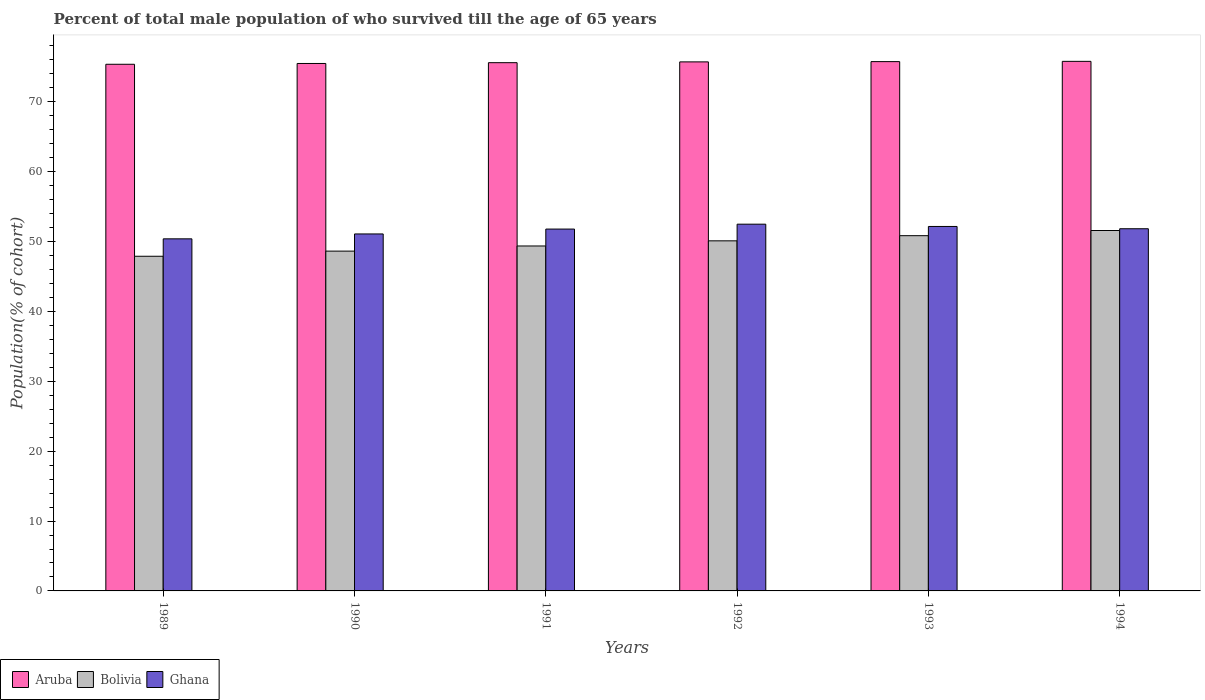How many different coloured bars are there?
Provide a short and direct response. 3. How many groups of bars are there?
Offer a very short reply. 6. Are the number of bars on each tick of the X-axis equal?
Give a very brief answer. Yes. How many bars are there on the 6th tick from the right?
Provide a succinct answer. 3. What is the label of the 5th group of bars from the left?
Offer a terse response. 1993. What is the percentage of total male population who survived till the age of 65 years in Bolivia in 1992?
Provide a short and direct response. 50.11. Across all years, what is the maximum percentage of total male population who survived till the age of 65 years in Ghana?
Keep it short and to the point. 52.5. Across all years, what is the minimum percentage of total male population who survived till the age of 65 years in Aruba?
Ensure brevity in your answer.  75.38. In which year was the percentage of total male population who survived till the age of 65 years in Aruba maximum?
Your response must be concise. 1994. In which year was the percentage of total male population who survived till the age of 65 years in Bolivia minimum?
Offer a terse response. 1989. What is the total percentage of total male population who survived till the age of 65 years in Ghana in the graph?
Your response must be concise. 309.8. What is the difference between the percentage of total male population who survived till the age of 65 years in Ghana in 1989 and that in 1991?
Keep it short and to the point. -1.4. What is the difference between the percentage of total male population who survived till the age of 65 years in Ghana in 1991 and the percentage of total male population who survived till the age of 65 years in Aruba in 1990?
Your answer should be very brief. -23.7. What is the average percentage of total male population who survived till the age of 65 years in Bolivia per year?
Make the answer very short. 49.74. In the year 1990, what is the difference between the percentage of total male population who survived till the age of 65 years in Bolivia and percentage of total male population who survived till the age of 65 years in Ghana?
Offer a terse response. -2.46. What is the ratio of the percentage of total male population who survived till the age of 65 years in Bolivia in 1991 to that in 1992?
Keep it short and to the point. 0.99. What is the difference between the highest and the second highest percentage of total male population who survived till the age of 65 years in Ghana?
Your answer should be very brief. 0.33. What is the difference between the highest and the lowest percentage of total male population who survived till the age of 65 years in Bolivia?
Make the answer very short. 3.68. In how many years, is the percentage of total male population who survived till the age of 65 years in Ghana greater than the average percentage of total male population who survived till the age of 65 years in Ghana taken over all years?
Your answer should be compact. 4. Is the sum of the percentage of total male population who survived till the age of 65 years in Aruba in 1989 and 1990 greater than the maximum percentage of total male population who survived till the age of 65 years in Bolivia across all years?
Ensure brevity in your answer.  Yes. What does the 1st bar from the right in 1989 represents?
Offer a terse response. Ghana. Are all the bars in the graph horizontal?
Provide a succinct answer. No. How many years are there in the graph?
Keep it short and to the point. 6. What is the difference between two consecutive major ticks on the Y-axis?
Your response must be concise. 10. Does the graph contain any zero values?
Keep it short and to the point. No. Does the graph contain grids?
Your response must be concise. No. How are the legend labels stacked?
Provide a short and direct response. Horizontal. What is the title of the graph?
Your answer should be very brief. Percent of total male population of who survived till the age of 65 years. Does "Fiji" appear as one of the legend labels in the graph?
Your answer should be very brief. No. What is the label or title of the X-axis?
Your answer should be very brief. Years. What is the label or title of the Y-axis?
Offer a terse response. Population(% of cohort). What is the Population(% of cohort) in Aruba in 1989?
Your answer should be very brief. 75.38. What is the Population(% of cohort) of Bolivia in 1989?
Give a very brief answer. 47.9. What is the Population(% of cohort) of Ghana in 1989?
Your answer should be very brief. 50.4. What is the Population(% of cohort) in Aruba in 1990?
Keep it short and to the point. 75.5. What is the Population(% of cohort) in Bolivia in 1990?
Keep it short and to the point. 48.64. What is the Population(% of cohort) in Ghana in 1990?
Offer a terse response. 51.1. What is the Population(% of cohort) of Aruba in 1991?
Provide a short and direct response. 75.61. What is the Population(% of cohort) of Bolivia in 1991?
Offer a very short reply. 49.37. What is the Population(% of cohort) in Ghana in 1991?
Give a very brief answer. 51.8. What is the Population(% of cohort) in Aruba in 1992?
Ensure brevity in your answer.  75.73. What is the Population(% of cohort) of Bolivia in 1992?
Give a very brief answer. 50.11. What is the Population(% of cohort) of Ghana in 1992?
Make the answer very short. 52.5. What is the Population(% of cohort) of Aruba in 1993?
Make the answer very short. 75.76. What is the Population(% of cohort) of Bolivia in 1993?
Make the answer very short. 50.85. What is the Population(% of cohort) in Ghana in 1993?
Give a very brief answer. 52.17. What is the Population(% of cohort) of Aruba in 1994?
Keep it short and to the point. 75.8. What is the Population(% of cohort) of Bolivia in 1994?
Provide a succinct answer. 51.59. What is the Population(% of cohort) of Ghana in 1994?
Make the answer very short. 51.84. Across all years, what is the maximum Population(% of cohort) in Aruba?
Provide a short and direct response. 75.8. Across all years, what is the maximum Population(% of cohort) in Bolivia?
Offer a very short reply. 51.59. Across all years, what is the maximum Population(% of cohort) of Ghana?
Make the answer very short. 52.5. Across all years, what is the minimum Population(% of cohort) in Aruba?
Provide a short and direct response. 75.38. Across all years, what is the minimum Population(% of cohort) in Bolivia?
Provide a short and direct response. 47.9. Across all years, what is the minimum Population(% of cohort) of Ghana?
Keep it short and to the point. 50.4. What is the total Population(% of cohort) in Aruba in the graph?
Your response must be concise. 453.78. What is the total Population(% of cohort) in Bolivia in the graph?
Make the answer very short. 298.46. What is the total Population(% of cohort) in Ghana in the graph?
Provide a succinct answer. 309.8. What is the difference between the Population(% of cohort) in Aruba in 1989 and that in 1990?
Offer a terse response. -0.11. What is the difference between the Population(% of cohort) of Bolivia in 1989 and that in 1990?
Make the answer very short. -0.74. What is the difference between the Population(% of cohort) of Ghana in 1989 and that in 1990?
Provide a short and direct response. -0.7. What is the difference between the Population(% of cohort) in Aruba in 1989 and that in 1991?
Ensure brevity in your answer.  -0.23. What is the difference between the Population(% of cohort) in Bolivia in 1989 and that in 1991?
Your response must be concise. -1.47. What is the difference between the Population(% of cohort) of Ghana in 1989 and that in 1991?
Your answer should be compact. -1.4. What is the difference between the Population(% of cohort) of Aruba in 1989 and that in 1992?
Keep it short and to the point. -0.34. What is the difference between the Population(% of cohort) in Bolivia in 1989 and that in 1992?
Make the answer very short. -2.21. What is the difference between the Population(% of cohort) in Ghana in 1989 and that in 1992?
Ensure brevity in your answer.  -2.1. What is the difference between the Population(% of cohort) of Aruba in 1989 and that in 1993?
Your answer should be compact. -0.38. What is the difference between the Population(% of cohort) of Bolivia in 1989 and that in 1993?
Give a very brief answer. -2.95. What is the difference between the Population(% of cohort) of Ghana in 1989 and that in 1993?
Make the answer very short. -1.77. What is the difference between the Population(% of cohort) in Aruba in 1989 and that in 1994?
Give a very brief answer. -0.42. What is the difference between the Population(% of cohort) in Bolivia in 1989 and that in 1994?
Your answer should be compact. -3.68. What is the difference between the Population(% of cohort) in Ghana in 1989 and that in 1994?
Offer a very short reply. -1.45. What is the difference between the Population(% of cohort) of Aruba in 1990 and that in 1991?
Keep it short and to the point. -0.11. What is the difference between the Population(% of cohort) of Bolivia in 1990 and that in 1991?
Your answer should be very brief. -0.74. What is the difference between the Population(% of cohort) in Ghana in 1990 and that in 1991?
Your response must be concise. -0.7. What is the difference between the Population(% of cohort) of Aruba in 1990 and that in 1992?
Give a very brief answer. -0.23. What is the difference between the Population(% of cohort) in Bolivia in 1990 and that in 1992?
Your response must be concise. -1.47. What is the difference between the Population(% of cohort) of Ghana in 1990 and that in 1992?
Offer a very short reply. -1.4. What is the difference between the Population(% of cohort) of Aruba in 1990 and that in 1993?
Offer a terse response. -0.27. What is the difference between the Population(% of cohort) in Bolivia in 1990 and that in 1993?
Keep it short and to the point. -2.21. What is the difference between the Population(% of cohort) in Ghana in 1990 and that in 1993?
Make the answer very short. -1.07. What is the difference between the Population(% of cohort) in Aruba in 1990 and that in 1994?
Your response must be concise. -0.3. What is the difference between the Population(% of cohort) in Bolivia in 1990 and that in 1994?
Your answer should be very brief. -2.95. What is the difference between the Population(% of cohort) of Ghana in 1990 and that in 1994?
Provide a succinct answer. -0.75. What is the difference between the Population(% of cohort) of Aruba in 1991 and that in 1992?
Ensure brevity in your answer.  -0.11. What is the difference between the Population(% of cohort) of Bolivia in 1991 and that in 1992?
Your answer should be very brief. -0.74. What is the difference between the Population(% of cohort) in Ghana in 1991 and that in 1992?
Give a very brief answer. -0.7. What is the difference between the Population(% of cohort) in Aruba in 1991 and that in 1993?
Make the answer very short. -0.15. What is the difference between the Population(% of cohort) in Bolivia in 1991 and that in 1993?
Ensure brevity in your answer.  -1.47. What is the difference between the Population(% of cohort) in Ghana in 1991 and that in 1993?
Offer a very short reply. -0.37. What is the difference between the Population(% of cohort) of Aruba in 1991 and that in 1994?
Offer a very short reply. -0.19. What is the difference between the Population(% of cohort) of Bolivia in 1991 and that in 1994?
Provide a short and direct response. -2.21. What is the difference between the Population(% of cohort) of Ghana in 1991 and that in 1994?
Make the answer very short. -0.05. What is the difference between the Population(% of cohort) of Aruba in 1992 and that in 1993?
Your answer should be very brief. -0.04. What is the difference between the Population(% of cohort) in Bolivia in 1992 and that in 1993?
Your response must be concise. -0.74. What is the difference between the Population(% of cohort) in Ghana in 1992 and that in 1993?
Make the answer very short. 0.33. What is the difference between the Population(% of cohort) in Aruba in 1992 and that in 1994?
Provide a succinct answer. -0.08. What is the difference between the Population(% of cohort) of Bolivia in 1992 and that in 1994?
Your answer should be very brief. -1.48. What is the difference between the Population(% of cohort) in Ghana in 1992 and that in 1994?
Make the answer very short. 0.65. What is the difference between the Population(% of cohort) of Aruba in 1993 and that in 1994?
Provide a succinct answer. -0.04. What is the difference between the Population(% of cohort) in Bolivia in 1993 and that in 1994?
Provide a short and direct response. -0.74. What is the difference between the Population(% of cohort) of Ghana in 1993 and that in 1994?
Your response must be concise. 0.33. What is the difference between the Population(% of cohort) in Aruba in 1989 and the Population(% of cohort) in Bolivia in 1990?
Offer a terse response. 26.74. What is the difference between the Population(% of cohort) in Aruba in 1989 and the Population(% of cohort) in Ghana in 1990?
Your answer should be very brief. 24.29. What is the difference between the Population(% of cohort) of Bolivia in 1989 and the Population(% of cohort) of Ghana in 1990?
Provide a short and direct response. -3.19. What is the difference between the Population(% of cohort) of Aruba in 1989 and the Population(% of cohort) of Bolivia in 1991?
Your answer should be compact. 26.01. What is the difference between the Population(% of cohort) in Aruba in 1989 and the Population(% of cohort) in Ghana in 1991?
Make the answer very short. 23.59. What is the difference between the Population(% of cohort) of Bolivia in 1989 and the Population(% of cohort) of Ghana in 1991?
Provide a succinct answer. -3.89. What is the difference between the Population(% of cohort) in Aruba in 1989 and the Population(% of cohort) in Bolivia in 1992?
Offer a terse response. 25.27. What is the difference between the Population(% of cohort) of Aruba in 1989 and the Population(% of cohort) of Ghana in 1992?
Keep it short and to the point. 22.89. What is the difference between the Population(% of cohort) in Bolivia in 1989 and the Population(% of cohort) in Ghana in 1992?
Make the answer very short. -4.59. What is the difference between the Population(% of cohort) in Aruba in 1989 and the Population(% of cohort) in Bolivia in 1993?
Your answer should be compact. 24.53. What is the difference between the Population(% of cohort) in Aruba in 1989 and the Population(% of cohort) in Ghana in 1993?
Your response must be concise. 23.21. What is the difference between the Population(% of cohort) of Bolivia in 1989 and the Population(% of cohort) of Ghana in 1993?
Provide a succinct answer. -4.27. What is the difference between the Population(% of cohort) in Aruba in 1989 and the Population(% of cohort) in Bolivia in 1994?
Your answer should be very brief. 23.8. What is the difference between the Population(% of cohort) of Aruba in 1989 and the Population(% of cohort) of Ghana in 1994?
Your answer should be very brief. 23.54. What is the difference between the Population(% of cohort) in Bolivia in 1989 and the Population(% of cohort) in Ghana in 1994?
Your response must be concise. -3.94. What is the difference between the Population(% of cohort) of Aruba in 1990 and the Population(% of cohort) of Bolivia in 1991?
Provide a succinct answer. 26.12. What is the difference between the Population(% of cohort) of Aruba in 1990 and the Population(% of cohort) of Ghana in 1991?
Offer a very short reply. 23.7. What is the difference between the Population(% of cohort) of Bolivia in 1990 and the Population(% of cohort) of Ghana in 1991?
Offer a terse response. -3.16. What is the difference between the Population(% of cohort) of Aruba in 1990 and the Population(% of cohort) of Bolivia in 1992?
Provide a short and direct response. 25.39. What is the difference between the Population(% of cohort) in Aruba in 1990 and the Population(% of cohort) in Ghana in 1992?
Make the answer very short. 23. What is the difference between the Population(% of cohort) in Bolivia in 1990 and the Population(% of cohort) in Ghana in 1992?
Ensure brevity in your answer.  -3.86. What is the difference between the Population(% of cohort) of Aruba in 1990 and the Population(% of cohort) of Bolivia in 1993?
Keep it short and to the point. 24.65. What is the difference between the Population(% of cohort) of Aruba in 1990 and the Population(% of cohort) of Ghana in 1993?
Offer a very short reply. 23.33. What is the difference between the Population(% of cohort) in Bolivia in 1990 and the Population(% of cohort) in Ghana in 1993?
Offer a terse response. -3.53. What is the difference between the Population(% of cohort) of Aruba in 1990 and the Population(% of cohort) of Bolivia in 1994?
Offer a very short reply. 23.91. What is the difference between the Population(% of cohort) of Aruba in 1990 and the Population(% of cohort) of Ghana in 1994?
Your answer should be very brief. 23.65. What is the difference between the Population(% of cohort) in Bolivia in 1990 and the Population(% of cohort) in Ghana in 1994?
Your response must be concise. -3.2. What is the difference between the Population(% of cohort) in Aruba in 1991 and the Population(% of cohort) in Bolivia in 1992?
Ensure brevity in your answer.  25.5. What is the difference between the Population(% of cohort) in Aruba in 1991 and the Population(% of cohort) in Ghana in 1992?
Ensure brevity in your answer.  23.12. What is the difference between the Population(% of cohort) in Bolivia in 1991 and the Population(% of cohort) in Ghana in 1992?
Keep it short and to the point. -3.12. What is the difference between the Population(% of cohort) in Aruba in 1991 and the Population(% of cohort) in Bolivia in 1993?
Give a very brief answer. 24.76. What is the difference between the Population(% of cohort) in Aruba in 1991 and the Population(% of cohort) in Ghana in 1993?
Offer a terse response. 23.44. What is the difference between the Population(% of cohort) in Bolivia in 1991 and the Population(% of cohort) in Ghana in 1993?
Provide a short and direct response. -2.79. What is the difference between the Population(% of cohort) of Aruba in 1991 and the Population(% of cohort) of Bolivia in 1994?
Provide a short and direct response. 24.02. What is the difference between the Population(% of cohort) of Aruba in 1991 and the Population(% of cohort) of Ghana in 1994?
Offer a very short reply. 23.77. What is the difference between the Population(% of cohort) in Bolivia in 1991 and the Population(% of cohort) in Ghana in 1994?
Make the answer very short. -2.47. What is the difference between the Population(% of cohort) of Aruba in 1992 and the Population(% of cohort) of Bolivia in 1993?
Provide a succinct answer. 24.88. What is the difference between the Population(% of cohort) in Aruba in 1992 and the Population(% of cohort) in Ghana in 1993?
Provide a succinct answer. 23.56. What is the difference between the Population(% of cohort) in Bolivia in 1992 and the Population(% of cohort) in Ghana in 1993?
Your answer should be compact. -2.06. What is the difference between the Population(% of cohort) of Aruba in 1992 and the Population(% of cohort) of Bolivia in 1994?
Ensure brevity in your answer.  24.14. What is the difference between the Population(% of cohort) of Aruba in 1992 and the Population(% of cohort) of Ghana in 1994?
Your response must be concise. 23.88. What is the difference between the Population(% of cohort) in Bolivia in 1992 and the Population(% of cohort) in Ghana in 1994?
Your response must be concise. -1.73. What is the difference between the Population(% of cohort) in Aruba in 1993 and the Population(% of cohort) in Bolivia in 1994?
Your answer should be very brief. 24.18. What is the difference between the Population(% of cohort) of Aruba in 1993 and the Population(% of cohort) of Ghana in 1994?
Make the answer very short. 23.92. What is the difference between the Population(% of cohort) in Bolivia in 1993 and the Population(% of cohort) in Ghana in 1994?
Your answer should be compact. -0.99. What is the average Population(% of cohort) of Aruba per year?
Provide a short and direct response. 75.63. What is the average Population(% of cohort) of Bolivia per year?
Your response must be concise. 49.74. What is the average Population(% of cohort) in Ghana per year?
Provide a short and direct response. 51.63. In the year 1989, what is the difference between the Population(% of cohort) of Aruba and Population(% of cohort) of Bolivia?
Offer a terse response. 27.48. In the year 1989, what is the difference between the Population(% of cohort) in Aruba and Population(% of cohort) in Ghana?
Keep it short and to the point. 24.99. In the year 1989, what is the difference between the Population(% of cohort) of Bolivia and Population(% of cohort) of Ghana?
Make the answer very short. -2.49. In the year 1990, what is the difference between the Population(% of cohort) of Aruba and Population(% of cohort) of Bolivia?
Your answer should be very brief. 26.86. In the year 1990, what is the difference between the Population(% of cohort) of Aruba and Population(% of cohort) of Ghana?
Provide a short and direct response. 24.4. In the year 1990, what is the difference between the Population(% of cohort) in Bolivia and Population(% of cohort) in Ghana?
Offer a terse response. -2.46. In the year 1991, what is the difference between the Population(% of cohort) in Aruba and Population(% of cohort) in Bolivia?
Keep it short and to the point. 26.24. In the year 1991, what is the difference between the Population(% of cohort) in Aruba and Population(% of cohort) in Ghana?
Your response must be concise. 23.82. In the year 1991, what is the difference between the Population(% of cohort) in Bolivia and Population(% of cohort) in Ghana?
Make the answer very short. -2.42. In the year 1992, what is the difference between the Population(% of cohort) of Aruba and Population(% of cohort) of Bolivia?
Provide a succinct answer. 25.62. In the year 1992, what is the difference between the Population(% of cohort) in Aruba and Population(% of cohort) in Ghana?
Provide a short and direct response. 23.23. In the year 1992, what is the difference between the Population(% of cohort) in Bolivia and Population(% of cohort) in Ghana?
Your response must be concise. -2.39. In the year 1993, what is the difference between the Population(% of cohort) in Aruba and Population(% of cohort) in Bolivia?
Your answer should be compact. 24.91. In the year 1993, what is the difference between the Population(% of cohort) of Aruba and Population(% of cohort) of Ghana?
Ensure brevity in your answer.  23.59. In the year 1993, what is the difference between the Population(% of cohort) in Bolivia and Population(% of cohort) in Ghana?
Offer a very short reply. -1.32. In the year 1994, what is the difference between the Population(% of cohort) of Aruba and Population(% of cohort) of Bolivia?
Provide a short and direct response. 24.21. In the year 1994, what is the difference between the Population(% of cohort) in Aruba and Population(% of cohort) in Ghana?
Your answer should be compact. 23.96. In the year 1994, what is the difference between the Population(% of cohort) in Bolivia and Population(% of cohort) in Ghana?
Give a very brief answer. -0.25. What is the ratio of the Population(% of cohort) in Aruba in 1989 to that in 1990?
Give a very brief answer. 1. What is the ratio of the Population(% of cohort) of Bolivia in 1989 to that in 1990?
Your answer should be compact. 0.98. What is the ratio of the Population(% of cohort) of Ghana in 1989 to that in 1990?
Offer a terse response. 0.99. What is the ratio of the Population(% of cohort) of Aruba in 1989 to that in 1991?
Your answer should be very brief. 1. What is the ratio of the Population(% of cohort) of Bolivia in 1989 to that in 1991?
Provide a succinct answer. 0.97. What is the ratio of the Population(% of cohort) in Bolivia in 1989 to that in 1992?
Provide a succinct answer. 0.96. What is the ratio of the Population(% of cohort) in Ghana in 1989 to that in 1992?
Provide a succinct answer. 0.96. What is the ratio of the Population(% of cohort) of Bolivia in 1989 to that in 1993?
Offer a very short reply. 0.94. What is the ratio of the Population(% of cohort) in Bolivia in 1989 to that in 1994?
Provide a succinct answer. 0.93. What is the ratio of the Population(% of cohort) of Ghana in 1989 to that in 1994?
Ensure brevity in your answer.  0.97. What is the ratio of the Population(% of cohort) of Aruba in 1990 to that in 1991?
Your response must be concise. 1. What is the ratio of the Population(% of cohort) in Bolivia in 1990 to that in 1991?
Provide a short and direct response. 0.99. What is the ratio of the Population(% of cohort) of Ghana in 1990 to that in 1991?
Offer a terse response. 0.99. What is the ratio of the Population(% of cohort) in Bolivia in 1990 to that in 1992?
Give a very brief answer. 0.97. What is the ratio of the Population(% of cohort) of Ghana in 1990 to that in 1992?
Offer a terse response. 0.97. What is the ratio of the Population(% of cohort) in Bolivia in 1990 to that in 1993?
Offer a very short reply. 0.96. What is the ratio of the Population(% of cohort) in Ghana in 1990 to that in 1993?
Your answer should be compact. 0.98. What is the ratio of the Population(% of cohort) in Bolivia in 1990 to that in 1994?
Offer a terse response. 0.94. What is the ratio of the Population(% of cohort) in Ghana in 1990 to that in 1994?
Your answer should be compact. 0.99. What is the ratio of the Population(% of cohort) of Aruba in 1991 to that in 1992?
Offer a terse response. 1. What is the ratio of the Population(% of cohort) in Ghana in 1991 to that in 1992?
Ensure brevity in your answer.  0.99. What is the ratio of the Population(% of cohort) of Aruba in 1991 to that in 1993?
Offer a terse response. 1. What is the ratio of the Population(% of cohort) of Bolivia in 1991 to that in 1993?
Offer a terse response. 0.97. What is the ratio of the Population(% of cohort) of Aruba in 1991 to that in 1994?
Make the answer very short. 1. What is the ratio of the Population(% of cohort) in Bolivia in 1991 to that in 1994?
Provide a succinct answer. 0.96. What is the ratio of the Population(% of cohort) of Ghana in 1991 to that in 1994?
Make the answer very short. 1. What is the ratio of the Population(% of cohort) of Aruba in 1992 to that in 1993?
Keep it short and to the point. 1. What is the ratio of the Population(% of cohort) of Bolivia in 1992 to that in 1993?
Your response must be concise. 0.99. What is the ratio of the Population(% of cohort) in Bolivia in 1992 to that in 1994?
Provide a short and direct response. 0.97. What is the ratio of the Population(% of cohort) in Ghana in 1992 to that in 1994?
Make the answer very short. 1.01. What is the ratio of the Population(% of cohort) of Aruba in 1993 to that in 1994?
Offer a terse response. 1. What is the ratio of the Population(% of cohort) in Bolivia in 1993 to that in 1994?
Keep it short and to the point. 0.99. What is the difference between the highest and the second highest Population(% of cohort) in Aruba?
Offer a terse response. 0.04. What is the difference between the highest and the second highest Population(% of cohort) in Bolivia?
Provide a succinct answer. 0.74. What is the difference between the highest and the second highest Population(% of cohort) of Ghana?
Ensure brevity in your answer.  0.33. What is the difference between the highest and the lowest Population(% of cohort) of Aruba?
Your answer should be very brief. 0.42. What is the difference between the highest and the lowest Population(% of cohort) of Bolivia?
Ensure brevity in your answer.  3.68. What is the difference between the highest and the lowest Population(% of cohort) in Ghana?
Keep it short and to the point. 2.1. 